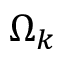<formula> <loc_0><loc_0><loc_500><loc_500>\Omega _ { k }</formula> 